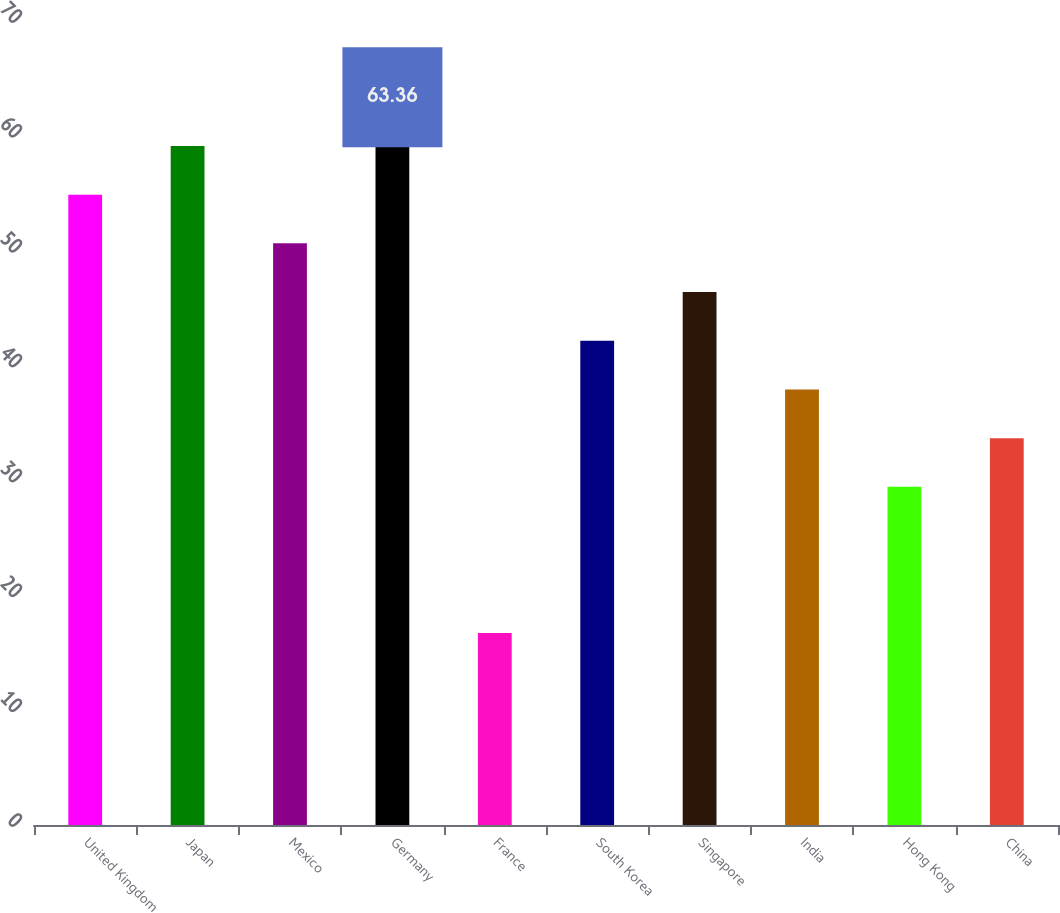Convert chart. <chart><loc_0><loc_0><loc_500><loc_500><bar_chart><fcel>United Kingdom<fcel>Japan<fcel>Mexico<fcel>Germany<fcel>France<fcel>South Korea<fcel>Singapore<fcel>India<fcel>Hong Kong<fcel>China<nl><fcel>54.88<fcel>59.12<fcel>50.64<fcel>63.36<fcel>16.72<fcel>42.16<fcel>46.4<fcel>37.92<fcel>29.44<fcel>33.68<nl></chart> 